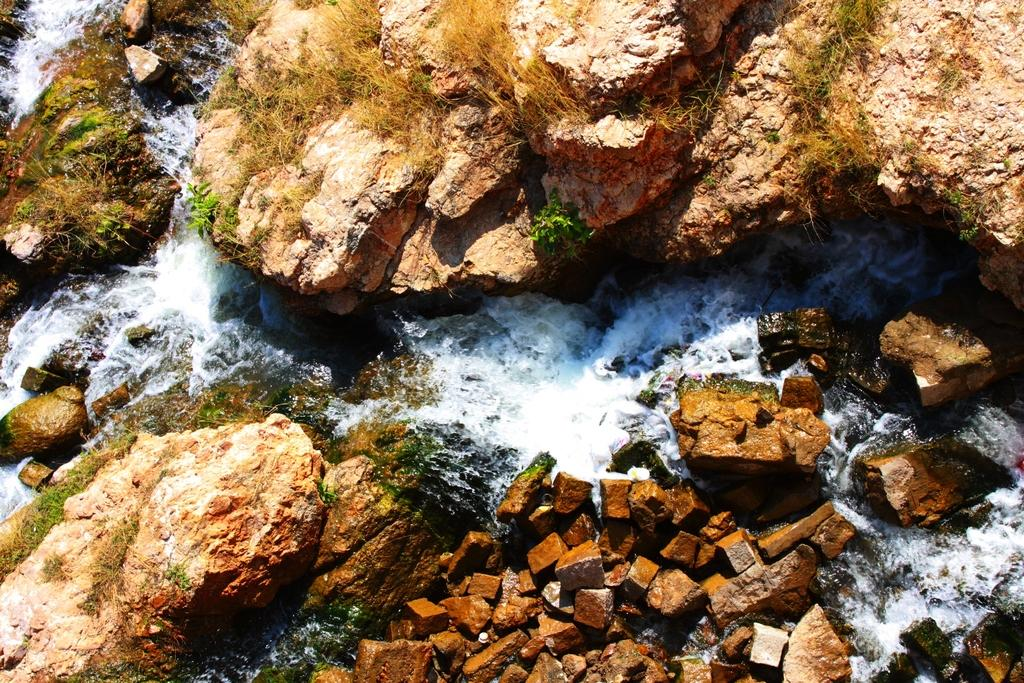What type of natural elements can be seen in the image? There are rocks, water, and plants in the image. How is the water depicted in the image? Water is flowing in the image. What kind of vegetation is present in the image? There are plants in the image. What type of trucks can be seen driving through the mouth in the image? There is no mouth or trucks present in the image; it features rocks, water, and plants. 